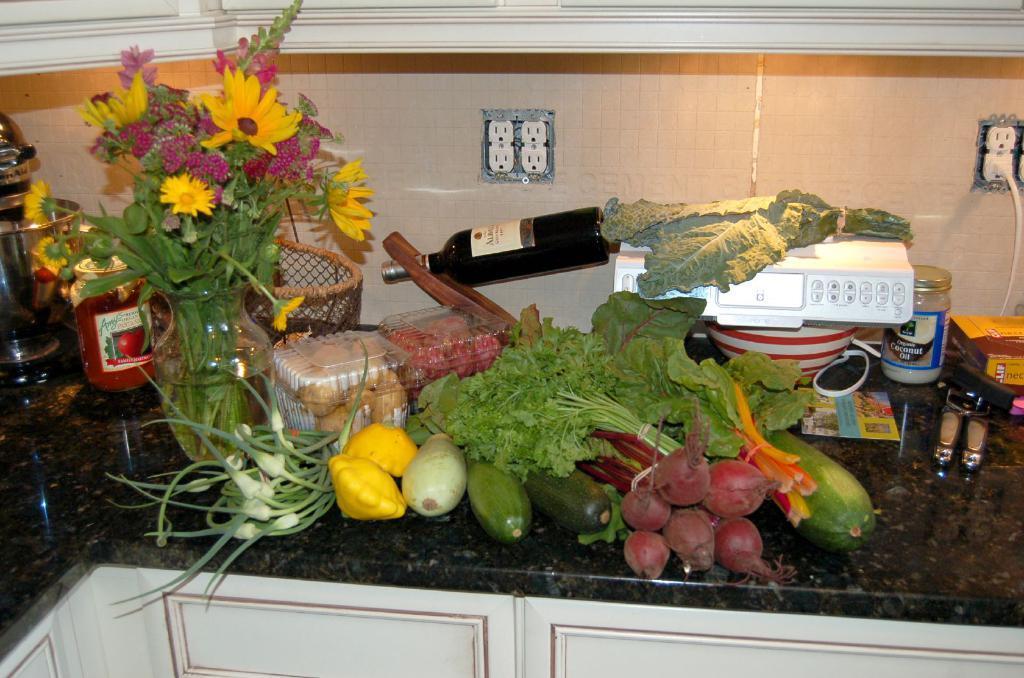Describe this image in one or two sentences. In this picture I can see few vegetables, couple of boxes, a weighing machine and I can see a flower vase and few bottles on the counter top and I can see few cupboards. 